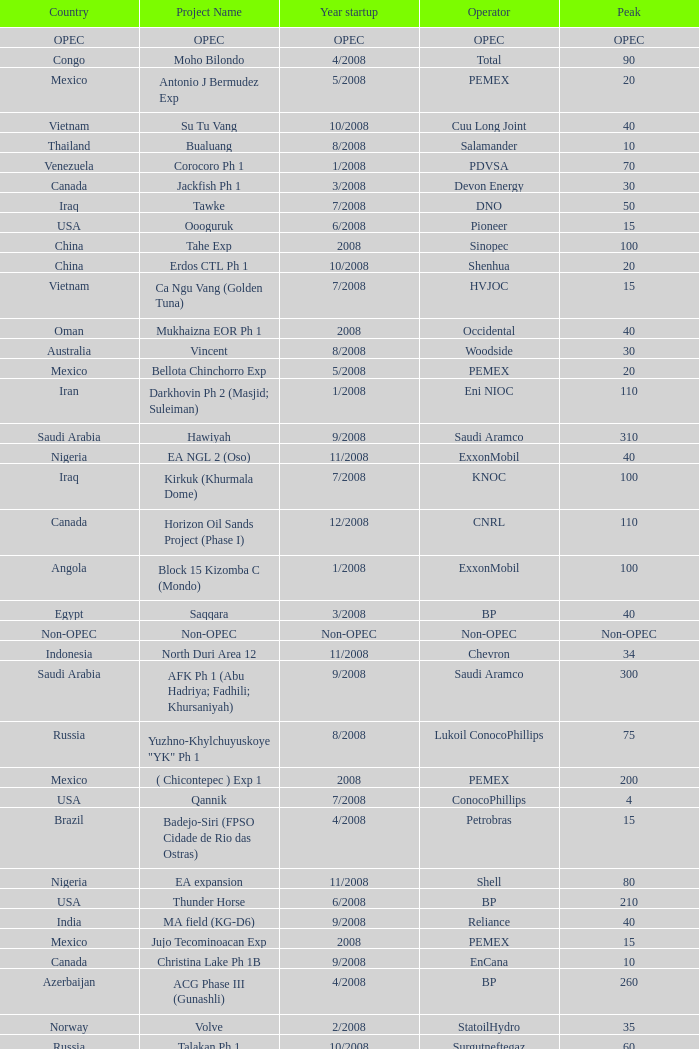What is the Project Name with a Country that is kazakhstan and a Peak that is 150? Dunga. 